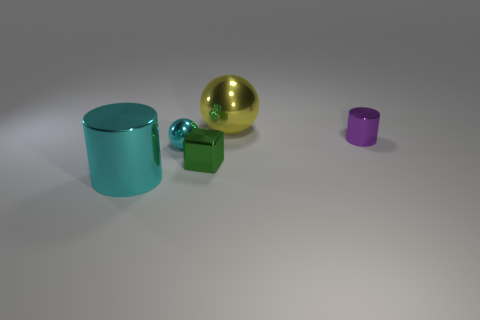What is the color of the cube that is the same material as the big cyan cylinder?
Provide a succinct answer. Green. There is a big object behind the metal cylinder behind the cyan shiny cylinder; what is it made of?
Provide a short and direct response. Metal. What number of things are shiny cylinders to the left of the tiny purple object or shiny cylinders behind the green metallic thing?
Keep it short and to the point. 2. There is a cyan metal thing behind the metallic cylinder that is to the left of the sphere that is to the left of the yellow object; what is its size?
Provide a succinct answer. Small. Are there the same number of big objects that are to the right of the green shiny thing and small spheres?
Ensure brevity in your answer.  Yes. Is there anything else that has the same shape as the tiny green thing?
Ensure brevity in your answer.  No. Is the shape of the tiny green metallic thing the same as the cyan metallic thing that is in front of the green cube?
Give a very brief answer. No. What size is the purple object that is the same shape as the big cyan object?
Give a very brief answer. Small. How many other things are made of the same material as the small cube?
Your answer should be very brief. 4. What material is the small ball?
Offer a terse response. Metal. 